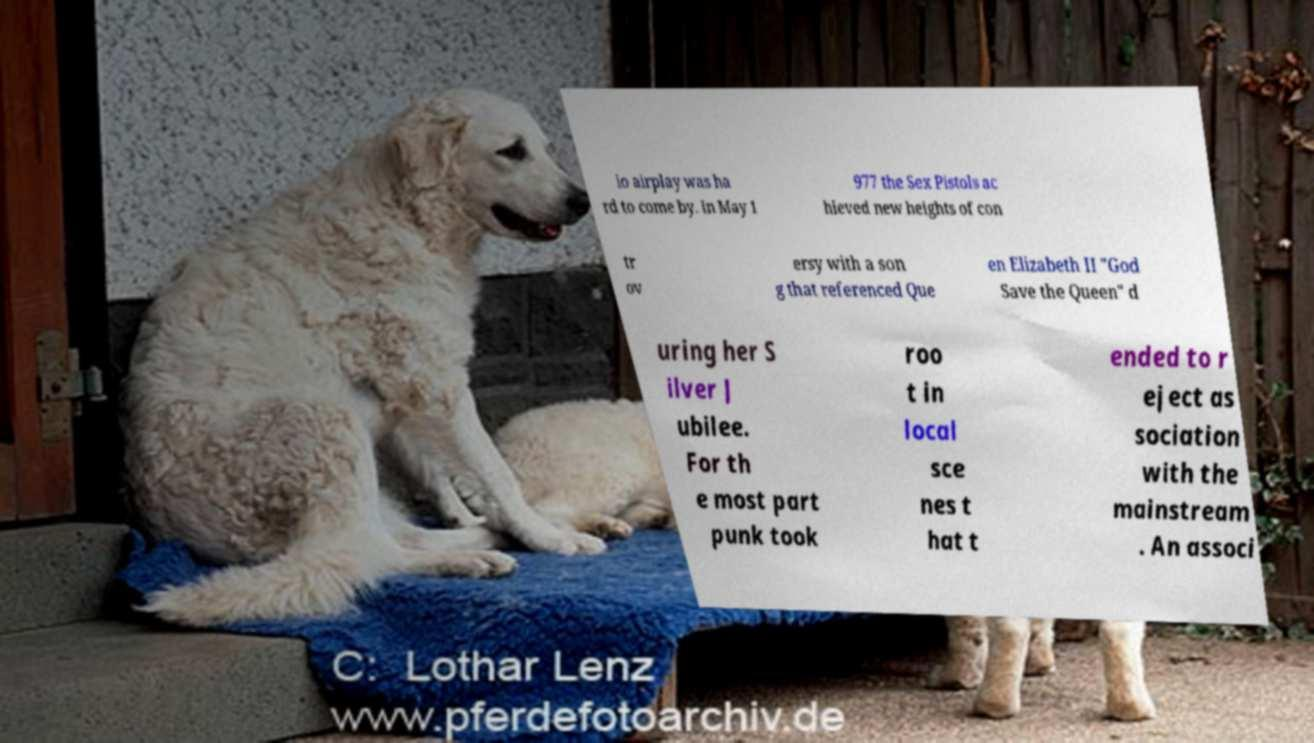Please identify and transcribe the text found in this image. io airplay was ha rd to come by. In May 1 977 the Sex Pistols ac hieved new heights of con tr ov ersy with a son g that referenced Que en Elizabeth II "God Save the Queen" d uring her S ilver J ubilee. For th e most part punk took roo t in local sce nes t hat t ended to r eject as sociation with the mainstream . An associ 